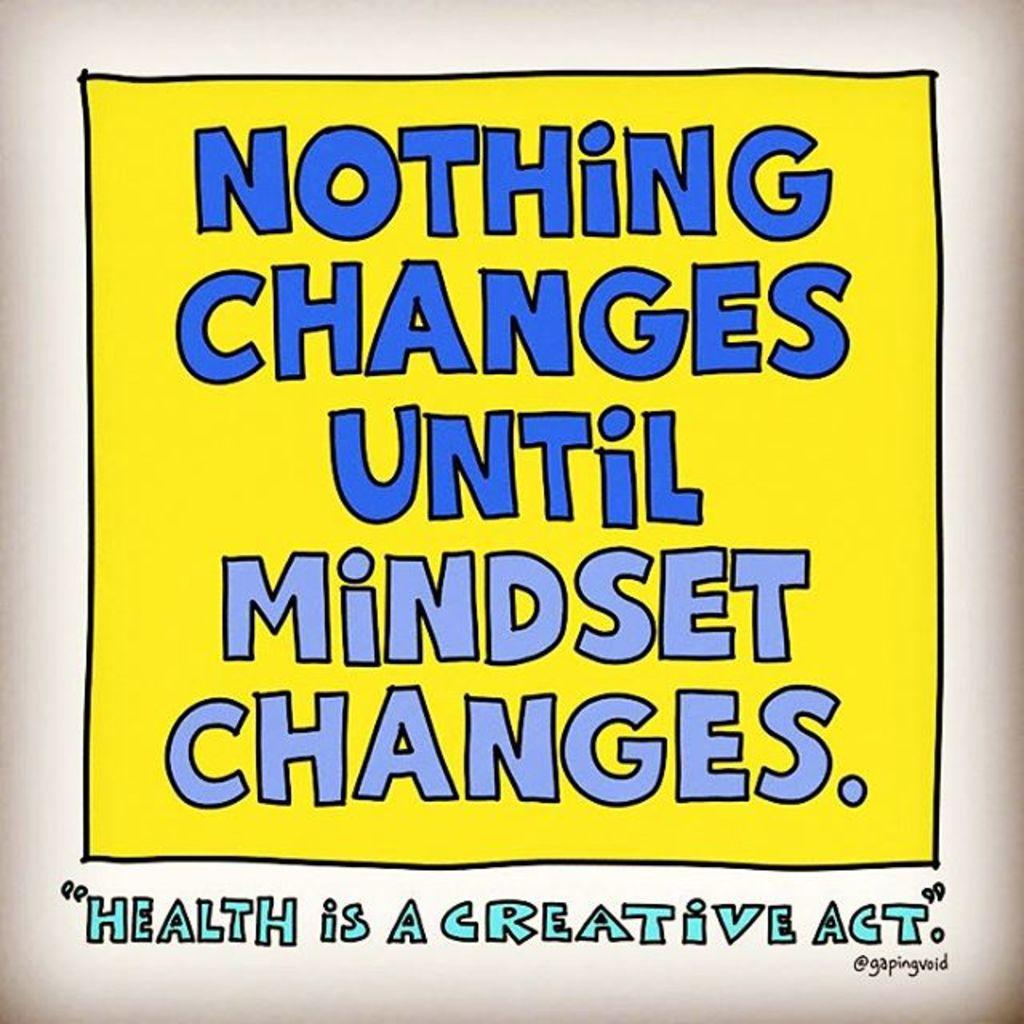<image>
Provide a brief description of the given image. An inspirational message about one's mindset is above an inspirational message about health. 